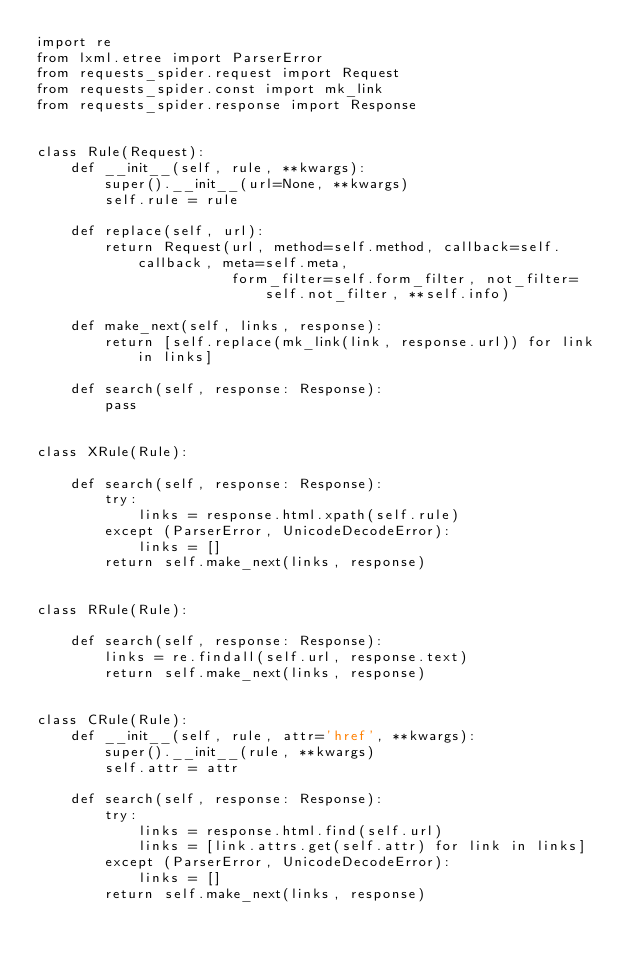Convert code to text. <code><loc_0><loc_0><loc_500><loc_500><_Python_>import re
from lxml.etree import ParserError
from requests_spider.request import Request
from requests_spider.const import mk_link
from requests_spider.response import Response


class Rule(Request):
    def __init__(self, rule, **kwargs):
        super().__init__(url=None, **kwargs)
        self.rule = rule

    def replace(self, url):
        return Request(url, method=self.method, callback=self.callback, meta=self.meta,
                       form_filter=self.form_filter, not_filter=self.not_filter, **self.info)

    def make_next(self, links, response):
        return [self.replace(mk_link(link, response.url)) for link in links]

    def search(self, response: Response):
        pass


class XRule(Rule):

    def search(self, response: Response):
        try:
            links = response.html.xpath(self.rule)
        except (ParserError, UnicodeDecodeError):
            links = []
        return self.make_next(links, response)


class RRule(Rule):

    def search(self, response: Response):
        links = re.findall(self.url, response.text)
        return self.make_next(links, response)


class CRule(Rule):
    def __init__(self, rule, attr='href', **kwargs):
        super().__init__(rule, **kwargs)
        self.attr = attr

    def search(self, response: Response):
        try:
            links = response.html.find(self.url)
            links = [link.attrs.get(self.attr) for link in links]
        except (ParserError, UnicodeDecodeError):
            links = []
        return self.make_next(links, response)
</code> 